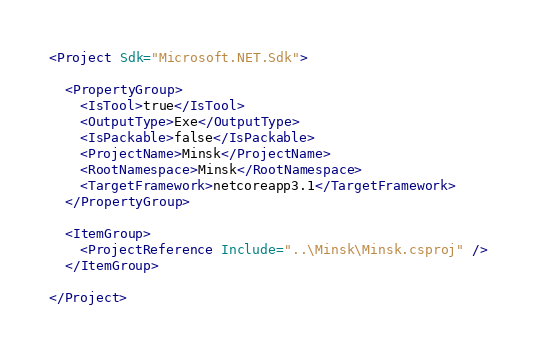<code> <loc_0><loc_0><loc_500><loc_500><_XML_><Project Sdk="Microsoft.NET.Sdk">

  <PropertyGroup>
    <IsTool>true</IsTool>
    <OutputType>Exe</OutputType>
    <IsPackable>false</IsPackable>
    <ProjectName>Minsk</ProjectName>
    <RootNamespace>Minsk</RootNamespace>
    <TargetFramework>netcoreapp3.1</TargetFramework>
  </PropertyGroup>

  <ItemGroup>
    <ProjectReference Include="..\Minsk\Minsk.csproj" />
  </ItemGroup>

</Project></code> 